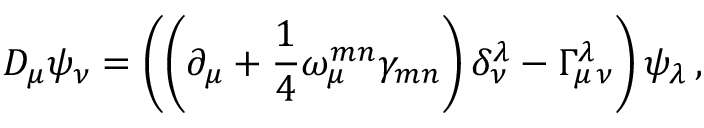<formula> <loc_0><loc_0><loc_500><loc_500>D _ { \mu } \psi _ { \nu } = \left ( \left ( \partial _ { \mu } + \frac { 1 } { 4 } \omega _ { \mu } ^ { m n } \gamma _ { m n } \right ) \delta _ { \nu } ^ { \lambda } - \Gamma _ { \mu \, \nu } ^ { \lambda } \right ) \psi _ { \lambda } \, ,</formula> 